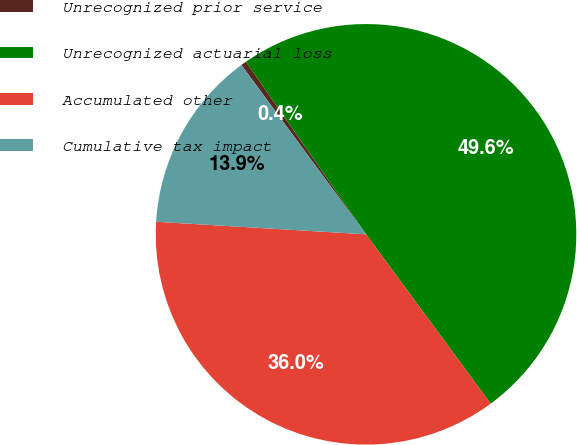Convert chart. <chart><loc_0><loc_0><loc_500><loc_500><pie_chart><fcel>Unrecognized prior service<fcel>Unrecognized actuarial loss<fcel>Accumulated other<fcel>Cumulative tax impact<nl><fcel>0.42%<fcel>49.58%<fcel>36.05%<fcel>13.95%<nl></chart> 